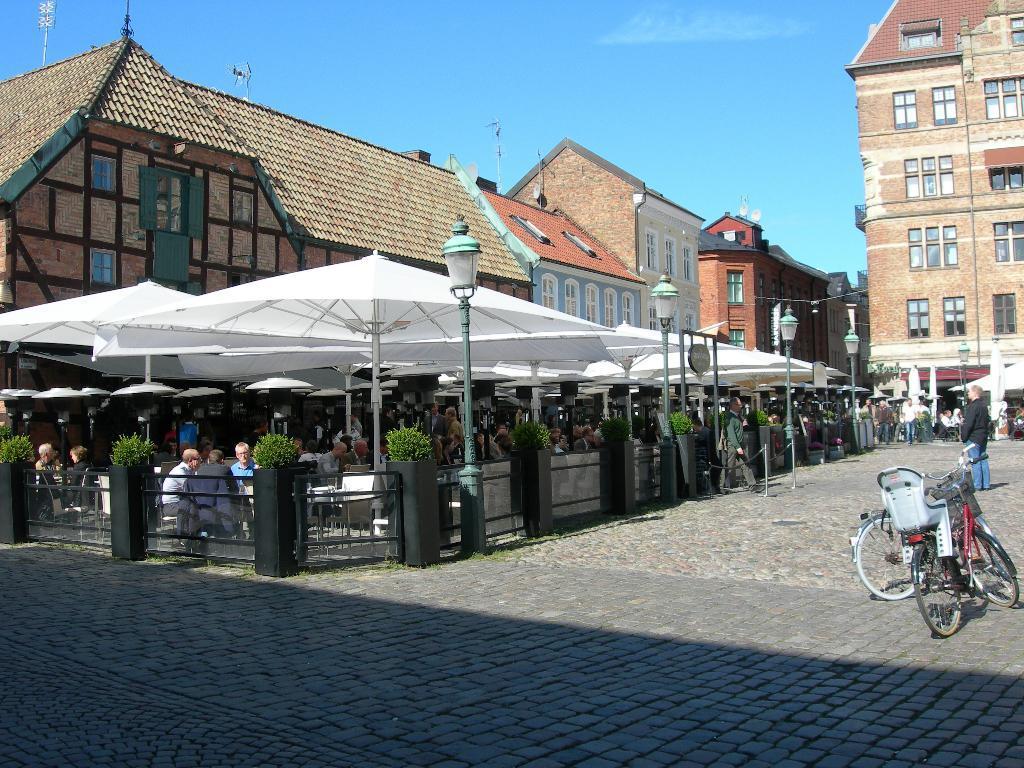Describe this image in one or two sentences. In this image I can see the ground, few bicycles on the ground, few persons standing on the ground, few plants, the railing, few poles, few white colored umbrellas and number of persons sitting on benches under the umbrellas. In the background I can see few buildings, few antennas on the buildings and the sky. 